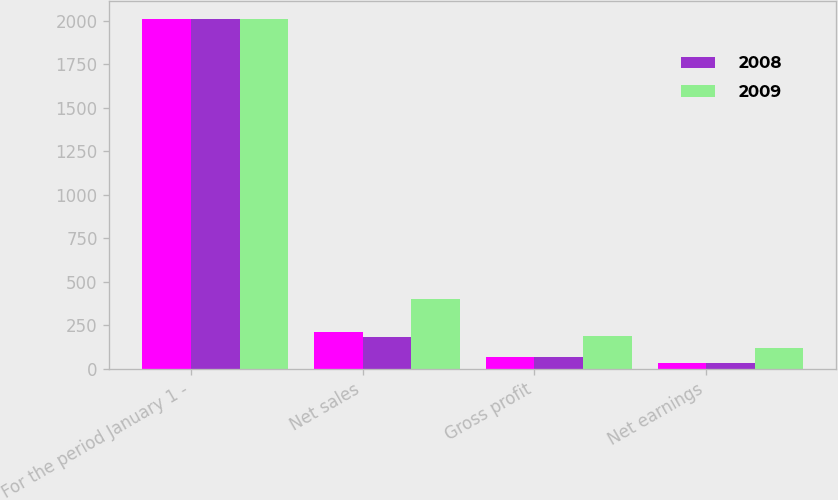Convert chart. <chart><loc_0><loc_0><loc_500><loc_500><stacked_bar_chart><ecel><fcel>For the period January 1 -<fcel>Net sales<fcel>Gross profit<fcel>Net earnings<nl><fcel>nan<fcel>2009<fcel>212.4<fcel>69.6<fcel>33.3<nl><fcel>2008<fcel>2008<fcel>182<fcel>69<fcel>34.3<nl><fcel>2009<fcel>2007<fcel>403.4<fcel>190.9<fcel>120.9<nl></chart> 